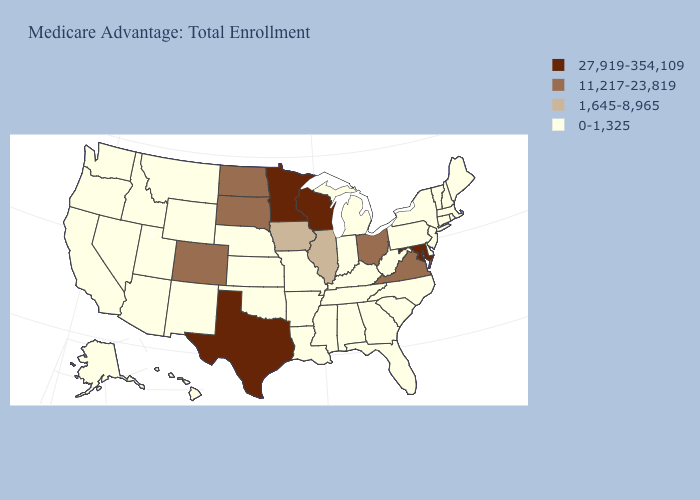What is the highest value in states that border Maryland?
Give a very brief answer. 11,217-23,819. Among the states that border Vermont , which have the lowest value?
Quick response, please. Massachusetts, New Hampshire, New York. What is the lowest value in states that border Louisiana?
Be succinct. 0-1,325. Name the states that have a value in the range 1,645-8,965?
Give a very brief answer. Iowa, Illinois. Does Wisconsin have the highest value in the USA?
Concise answer only. Yes. Does Texas have the same value as Nebraska?
Short answer required. No. Name the states that have a value in the range 1,645-8,965?
Be succinct. Iowa, Illinois. What is the value of Georgia?
Quick response, please. 0-1,325. Name the states that have a value in the range 1,645-8,965?
Quick response, please. Iowa, Illinois. Name the states that have a value in the range 11,217-23,819?
Write a very short answer. Colorado, North Dakota, Ohio, South Dakota, Virginia. What is the lowest value in the West?
Give a very brief answer. 0-1,325. What is the highest value in the Northeast ?
Quick response, please. 0-1,325. What is the value of Washington?
Short answer required. 0-1,325. Does Montana have the lowest value in the USA?
Write a very short answer. Yes. Name the states that have a value in the range 0-1,325?
Answer briefly. Alaska, Alabama, Arkansas, Arizona, California, Connecticut, Delaware, Florida, Georgia, Hawaii, Idaho, Indiana, Kansas, Kentucky, Louisiana, Massachusetts, Maine, Michigan, Missouri, Mississippi, Montana, North Carolina, Nebraska, New Hampshire, New Jersey, New Mexico, Nevada, New York, Oklahoma, Oregon, Pennsylvania, Rhode Island, South Carolina, Tennessee, Utah, Vermont, Washington, West Virginia, Wyoming. 